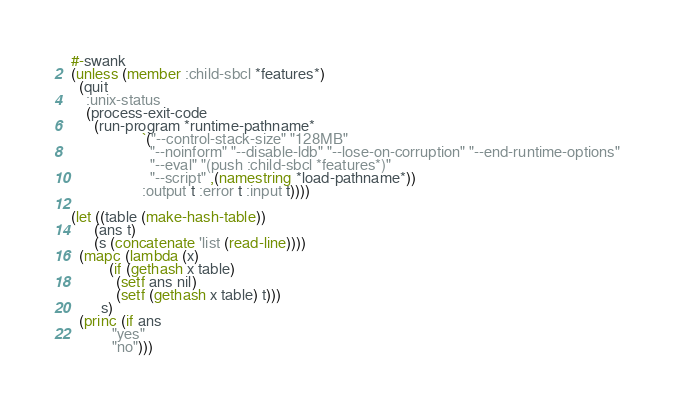<code> <loc_0><loc_0><loc_500><loc_500><_Lisp_>#-swank
(unless (member :child-sbcl *features*)
  (quit
	:unix-status
	(process-exit-code
	  (run-program *runtime-pathname*
				   `("--control-stack-size" "128MB"
					 "--noinform" "--disable-ldb" "--lose-on-corruption" "--end-runtime-options"
					 "--eval" "(push :child-sbcl *features*)"
					 "--script" ,(namestring *load-pathname*))
				   :output t :error t :input t))))

(let ((table (make-hash-table))
	  (ans t)
	  (s (concatenate 'list (read-line))))
  (mapc (lambda (x)
		  (if (gethash x table)
			(setf ans nil)
			(setf (gethash x table) t)))
		s)
  (princ (if ans
		   "yes"
		   "no")))
</code> 